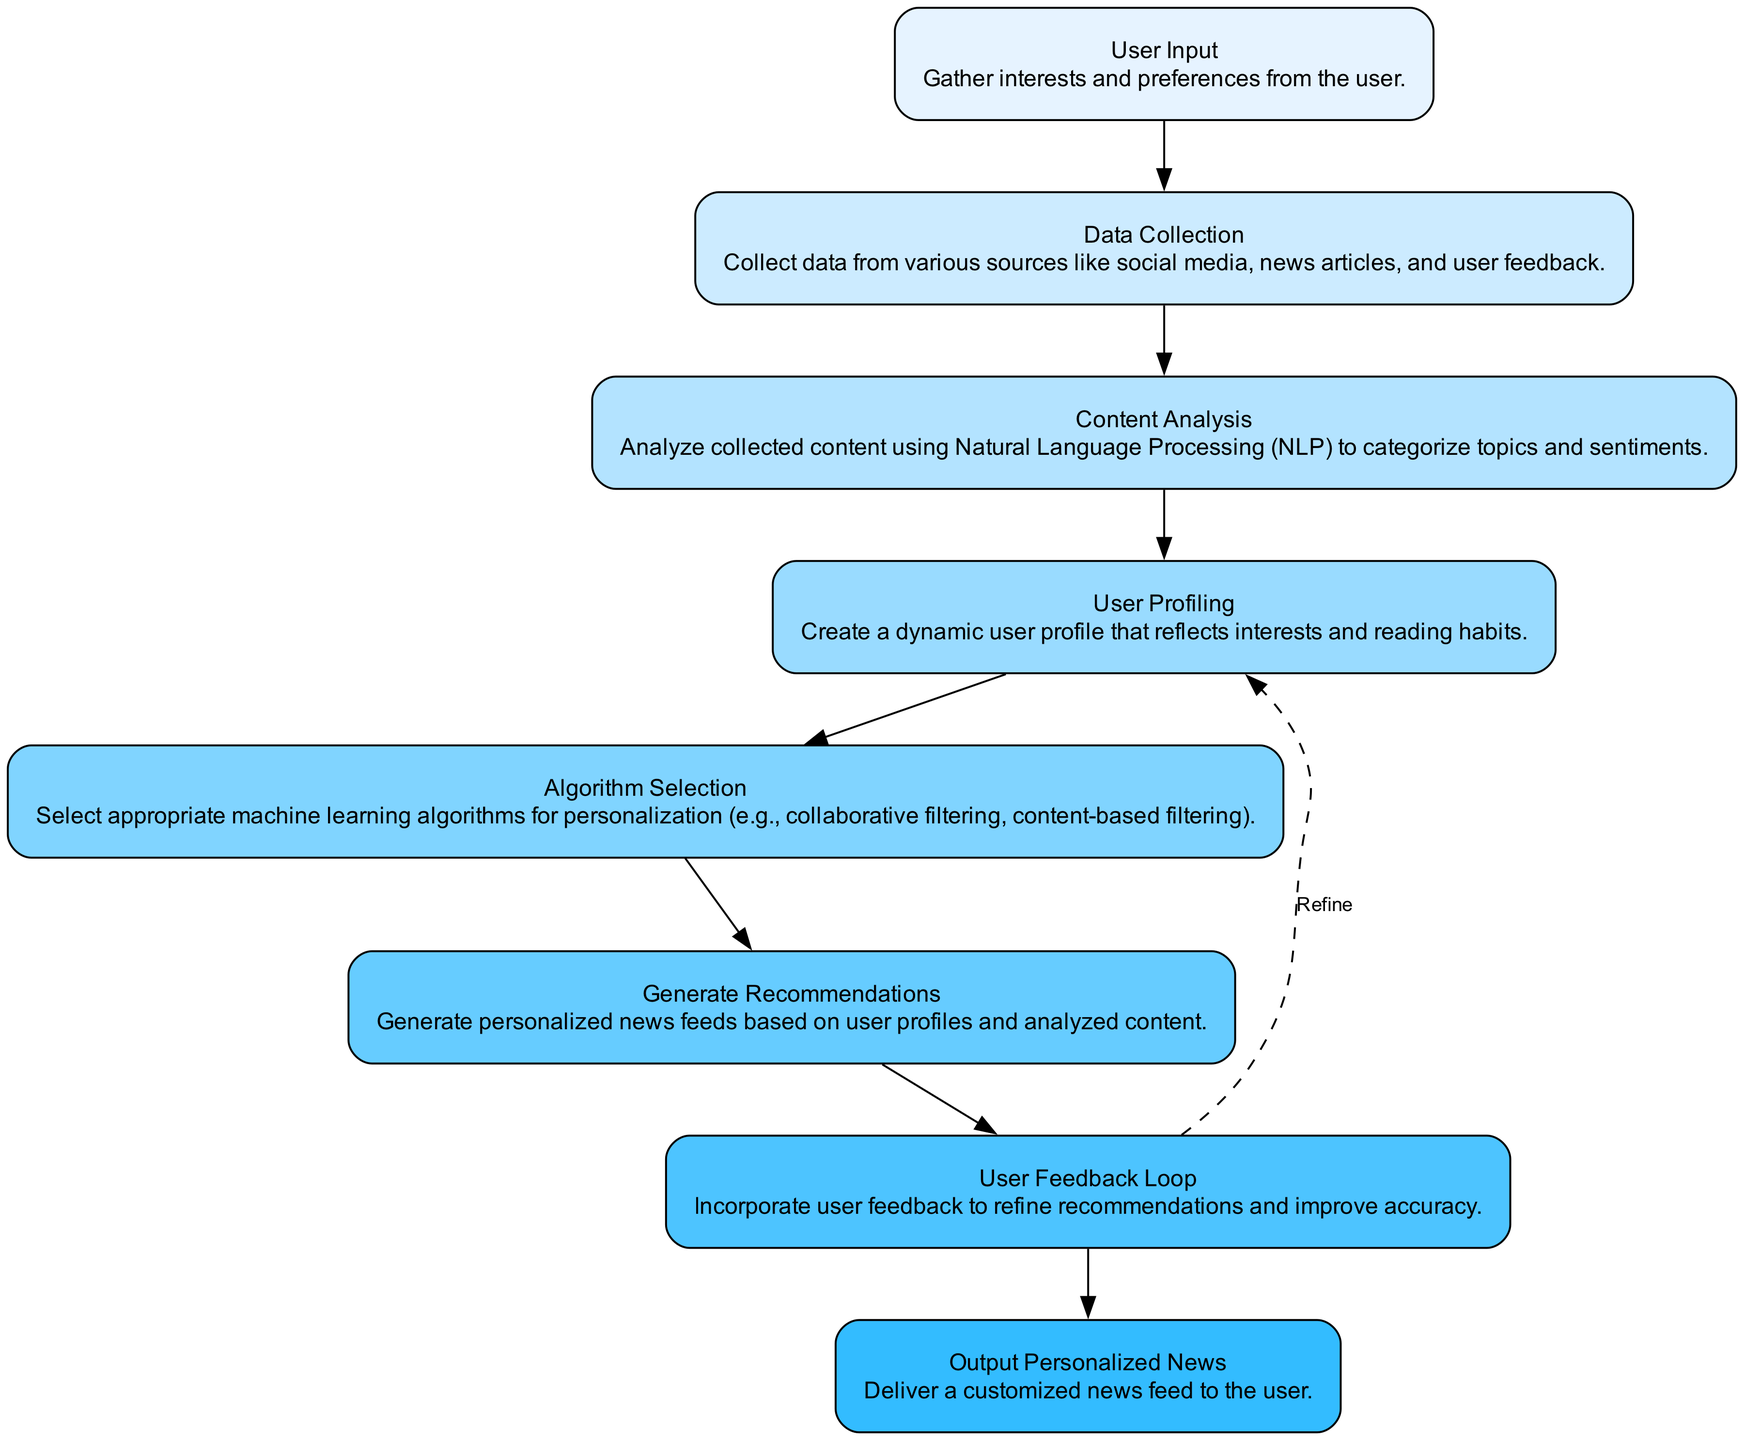What is the first step in the workflow? The first step in the workflow is represented by the "User Input" node, where interests and preferences are gathered from the user.
Answer: User Input How many nodes are in the diagram? By counting the individual nodes represented in the diagram, we find a total of eight distinct nodes that represent different stages in the process.
Answer: 8 Which node represents the analysis of content? The node labeled "Content Analysis" corresponds to the step where collected content is analyzed using Natural Language Processing to categorize topics and sentiments.
Answer: Content Analysis What type of edge connects the "User Feedback Loop" to the "User Profiling" node? The edge connecting the "User Feedback Loop" to the "User Profiling" node is represented as a dashed line, indicating a feedback mechanism that refines user profiles based on input.
Answer: Dashed What is the outcome of the algorithm after delivering results? The outcome is represented by the node "Output Personalized News," indicating that the user receives a customized news feed based on the earlier stages of the workflow.
Answer: Output Personalized News What happens after "Algorithm Selection"? After the "Algorithm Selection," the next step is "Generate Recommendations," where personalized news feeds are created according to user profiles and analyzed content.
Answer: Generate Recommendations Which node directly follows "Data Collection"? The node that directly follows "Data Collection" is "Content Analysis," reflecting the logical sequence where collected data is analyzed next.
Answer: Content Analysis Is there a feedback mechanism in this workflow? Yes, the diagram includes a feedback loop that allows user feedback to refine recommendations, indicating an iterative process for improving accuracy.
Answer: Yes What describes the relationship between "User Profiling" and "Generate Recommendations"? "User Profiling" directly influences "Generate Recommendations," as a dynamic user profile is essential for tailoring news feeds accurately to the user's interests.
Answer: Direct influence 